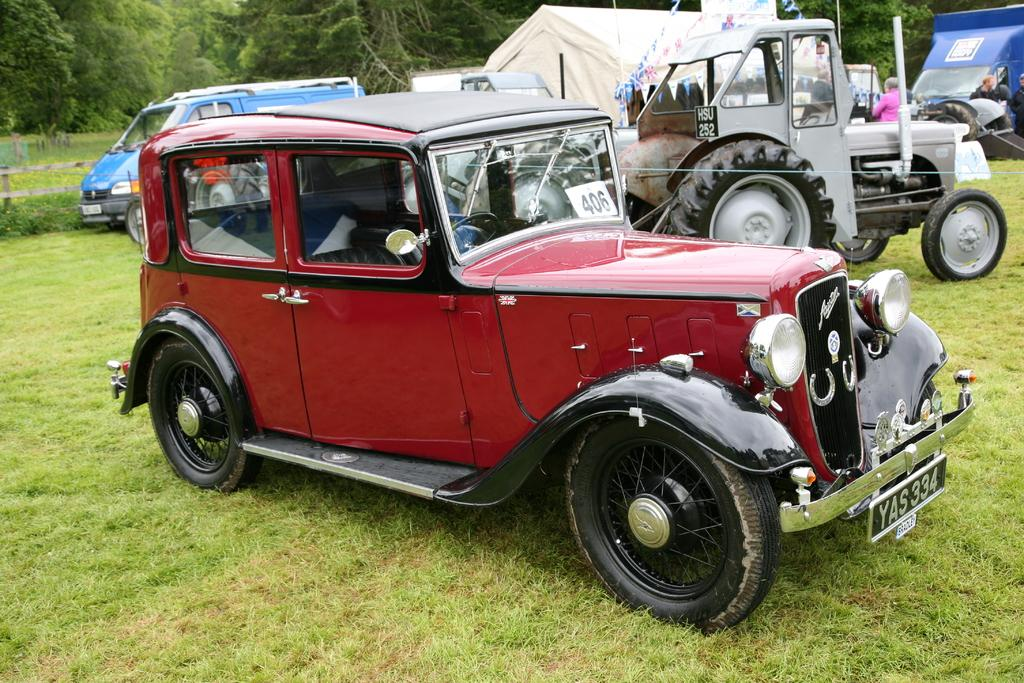What is located on the grass in the image? There are vehicles on the grass in the image. Can you describe the people in the image? There are people in the image. What additional decorative elements can be seen? There are decorative flags in the image. What type of barrier is present in the image? There is a fence in the image. What type of shelter is visible in the image? There is a canopy tent in the image. What can be seen in the background of the image? There are trees in the background of the image. Can you tell me how many dogs are sitting under the table in the image? There is no table or dog present in the image. What type of airplane can be seen flying over the canopy tent in the image? There is no airplane visible in the image; it only features vehicles, people, decorative flags, a fence, a canopy tent, and trees in the background. 